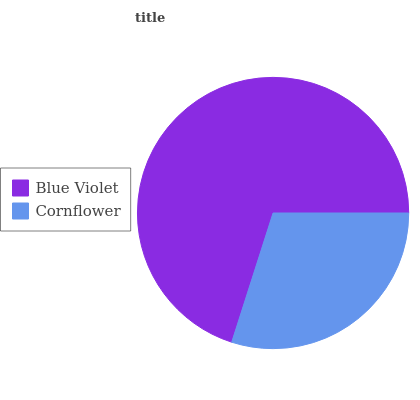Is Cornflower the minimum?
Answer yes or no. Yes. Is Blue Violet the maximum?
Answer yes or no. Yes. Is Cornflower the maximum?
Answer yes or no. No. Is Blue Violet greater than Cornflower?
Answer yes or no. Yes. Is Cornflower less than Blue Violet?
Answer yes or no. Yes. Is Cornflower greater than Blue Violet?
Answer yes or no. No. Is Blue Violet less than Cornflower?
Answer yes or no. No. Is Blue Violet the high median?
Answer yes or no. Yes. Is Cornflower the low median?
Answer yes or no. Yes. Is Cornflower the high median?
Answer yes or no. No. Is Blue Violet the low median?
Answer yes or no. No. 